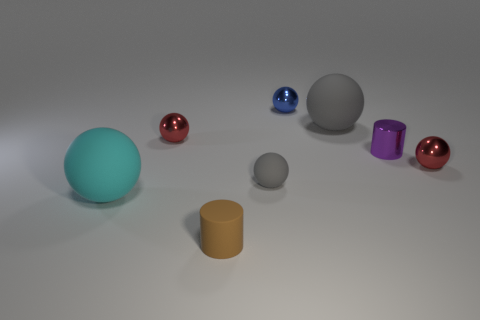Do the purple thing and the cyan sphere have the same size?
Your response must be concise. No. What is the size of the red thing left of the large thing that is behind the big cyan rubber thing?
Make the answer very short. Small. Is the tiny brown object the same shape as the small purple shiny thing?
Your answer should be compact. Yes. There is a large thing that is the same color as the small rubber sphere; what is its shape?
Offer a very short reply. Sphere. What number of rubber objects are cyan things or purple things?
Your response must be concise. 1. There is a tiny cylinder that is to the right of the gray sphere that is behind the tiny red thing on the left side of the purple object; what color is it?
Provide a short and direct response. Purple. What is the color of the other thing that is the same shape as the small brown matte object?
Your answer should be very brief. Purple. Are there any other things that are the same color as the tiny matte sphere?
Make the answer very short. Yes. How many other things are there of the same material as the small gray object?
Provide a short and direct response. 3. The purple cylinder is what size?
Keep it short and to the point. Small. 